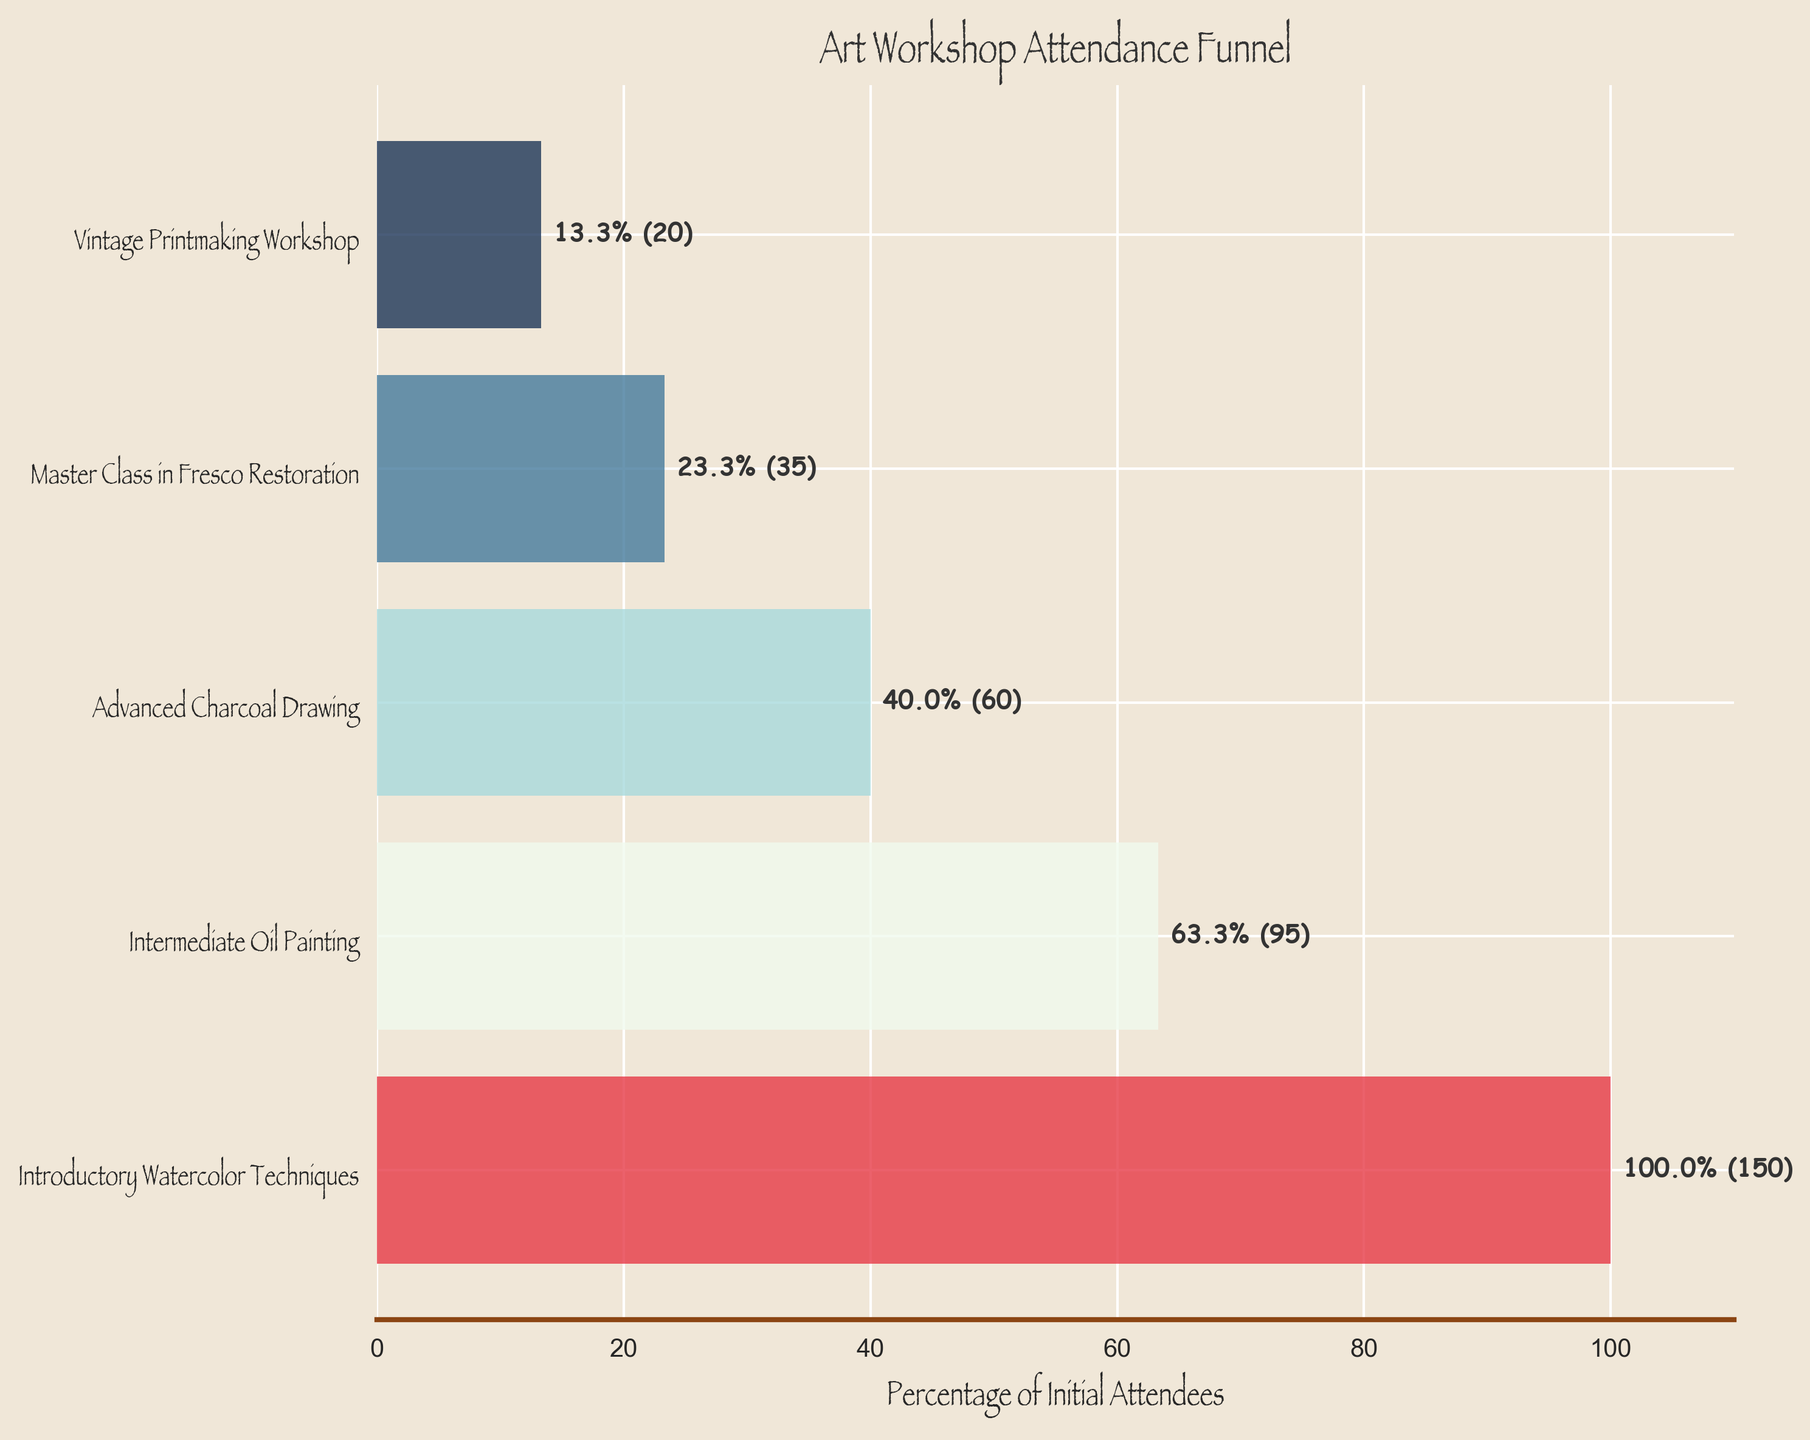What is the title of the funnel chart? The title of a chart is typically located at the top and provides a summary description of the chart. In this case, it reads "Art Workshop Attendance Funnel"
Answer: Art Workshop Attendance Funnel What are the stages listed on the vertical axis? The vertical axis lists the different stages of the art workshops. By reading the axis from top to bottom, we see: "Introductory Watercolor Techniques," "Intermediate Oil Painting," "Advanced Charcoal Drawing," "Master Class in Fresco Restoration," and "Vintage Printmaking Workshop"
Answer: Introductory Watercolor Techniques, Intermediate Oil Painting, Advanced Charcoal Drawing, Master Class in Fresco Restoration, Vintage Printmaking Workshop Which stage has the highest number of attendees? The stage with the highest number of attendees is the first bar in the funnel chart. It is "Introductory Watercolor Techniques" with 150 attendees
Answer: Introductory Watercolor Techniques What is the percentage of attendees for the Vintage Printmaking Workshop compared to the initial attendees? To find this percentage, we look for the label on the bar corresponding to "Vintage Printmaking Workshop." The label shows the percentage, which is 13.3%
Answer: 13.3% How many attendees are there in the Advanced Charcoal Drawing workshop? The number of attendees for each stage is shown as part of the label on each bar. For the Advanced Charcoal Drawing workshop, the label shows 60 attendees
Answer: 60 Compare the number of attendees for the Master Class in Fresco Restoration to the number for the Advanced Charcoal Drawing workshop. Which stage has more attendees? By comparing the labels on the corresponding bars, we see that the Advanced Charcoal Drawing workshop has 60 attendees, while the Master Class in Fresco Restoration has 35 attendees. Therefore, the Advanced Charcoal Drawing workshop has more attendees
Answer: Advanced Charcoal Drawing What is the percentage drop in attendees from "Introductory Watercolor Techniques" to "Intermediate Oil Painting"? To calculate the percentage drop, we use the formula: ((Initial - Later) / Initial) * 100. The initial number of attendees is 150 and the later stage has 95 attendees. Thus, ((150 - 95) / 150) * 100 = 36.7%
Answer: 36.7% Which two stages have the closest number of attendees? Comparing the attendee numbers: Introductory Watercolor Techniques (150), Intermediate Oil Painting (95), Advanced Charcoal Drawing (60), Master Class in Fresco Restoration (35), and Vintage Printmaking Workshop (20), the closest numbers are 35 and 20 for Master Class in Fresco Restoration and Vintage Printmaking Workshop
Answer: Master Class in Fresco Restoration and Vintage Printmaking Workshop What is the combined total of attendees for all the workshops? Adding up the number of attendees for all the workshops: 150 (Introductory) + 95 (Intermediate) + 60 (Advanced) + 35 (Master Class) + 20 (Vintage) equals 360 attendees in total
Answer: 360 What is the average percentage of attendees who moved to the next stage, starting from the initial attendees? Find the percentage of attendees for each subsequent stage: Intermediate (63.3%), Advanced (40%), Master Class (23.3%), Vintage (13.3%). Calculate the average: (63.3 + 40 + 23.3 + 13.3) / 4 = 35%
Answer: 35% 